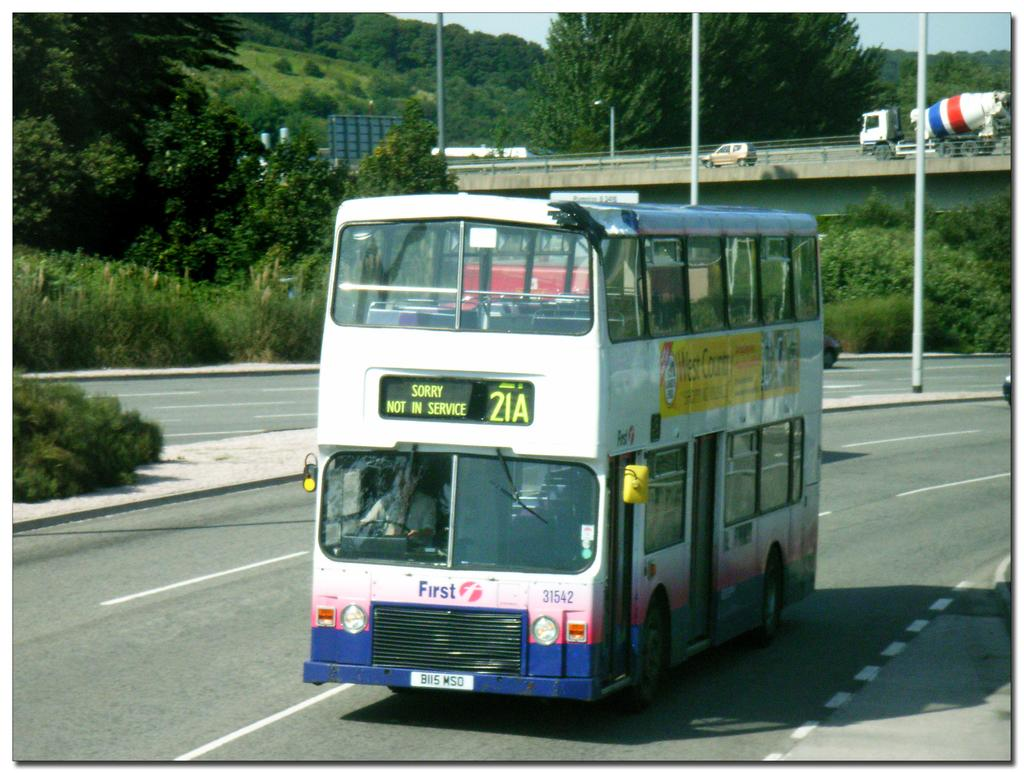<image>
Share a concise interpretation of the image provided. Double decker bus on the road that is not in service. 